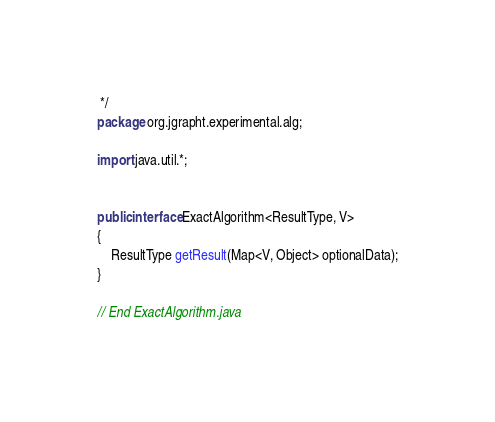Convert code to text. <code><loc_0><loc_0><loc_500><loc_500><_Java_> */
package org.jgrapht.experimental.alg;

import java.util.*;


public interface ExactAlgorithm<ResultType, V>
{
    ResultType getResult(Map<V, Object> optionalData);
}

// End ExactAlgorithm.java
</code> 